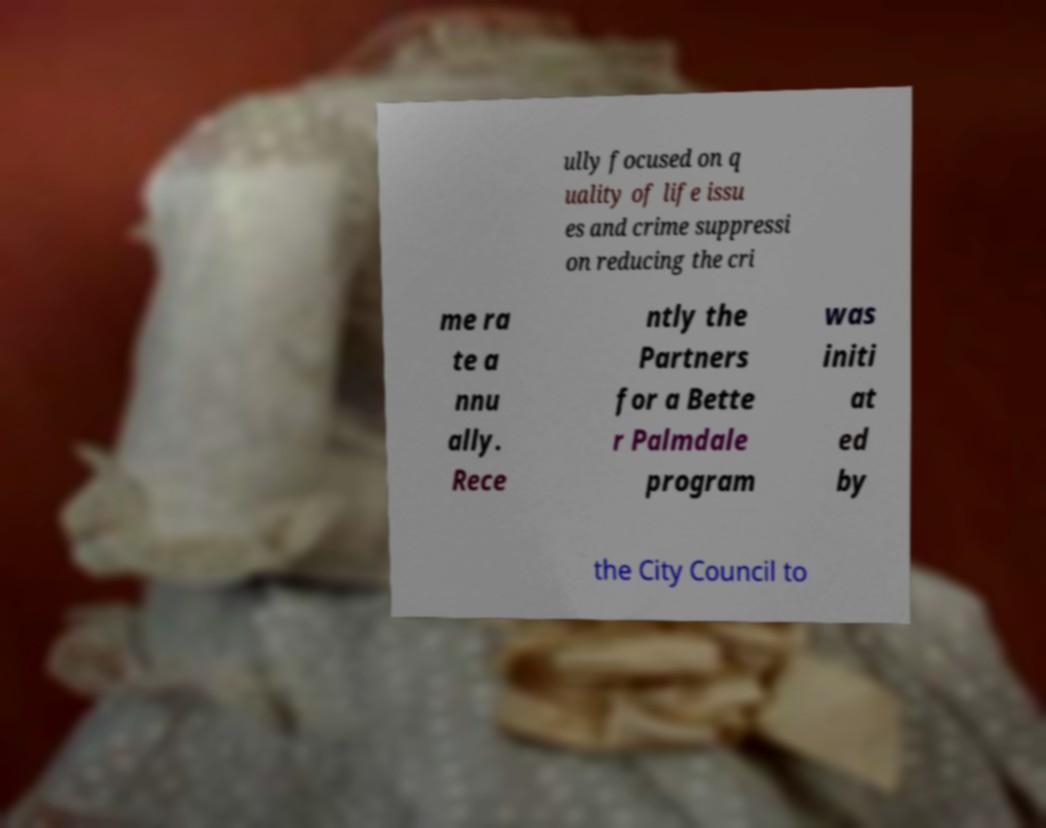For documentation purposes, I need the text within this image transcribed. Could you provide that? ully focused on q uality of life issu es and crime suppressi on reducing the cri me ra te a nnu ally. Rece ntly the Partners for a Bette r Palmdale program was initi at ed by the City Council to 